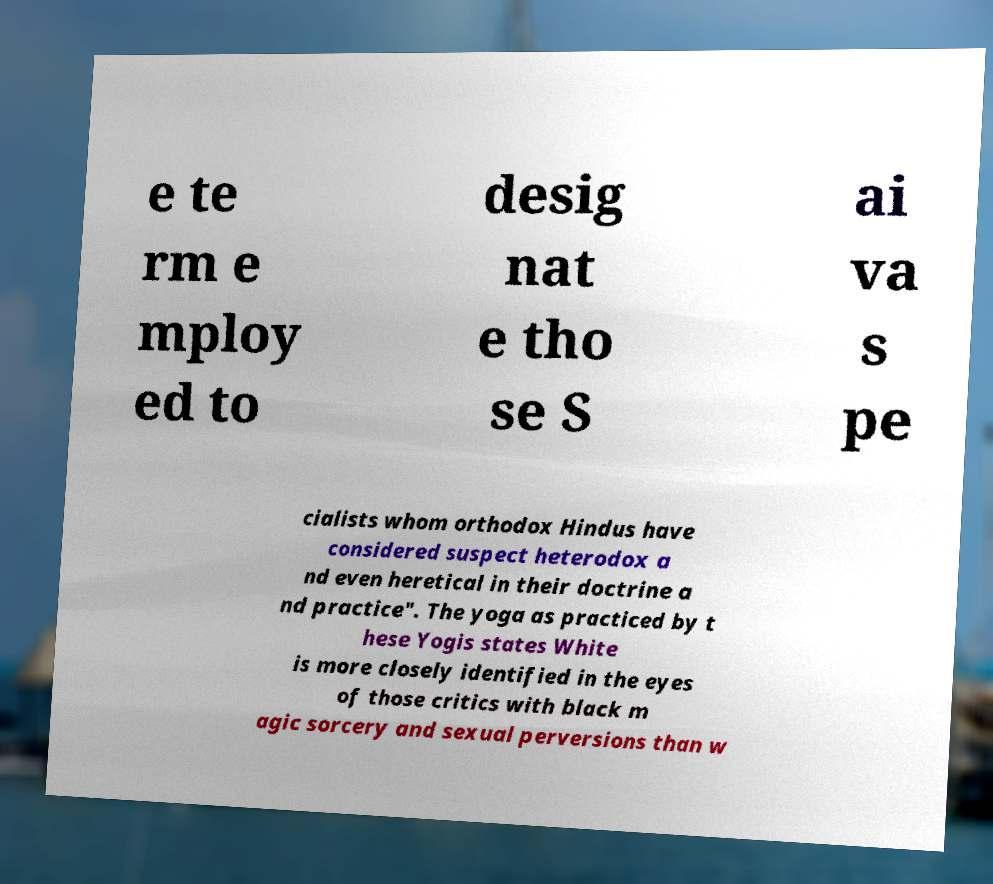Could you assist in decoding the text presented in this image and type it out clearly? e te rm e mploy ed to desig nat e tho se S ai va s pe cialists whom orthodox Hindus have considered suspect heterodox a nd even heretical in their doctrine a nd practice". The yoga as practiced by t hese Yogis states White is more closely identified in the eyes of those critics with black m agic sorcery and sexual perversions than w 